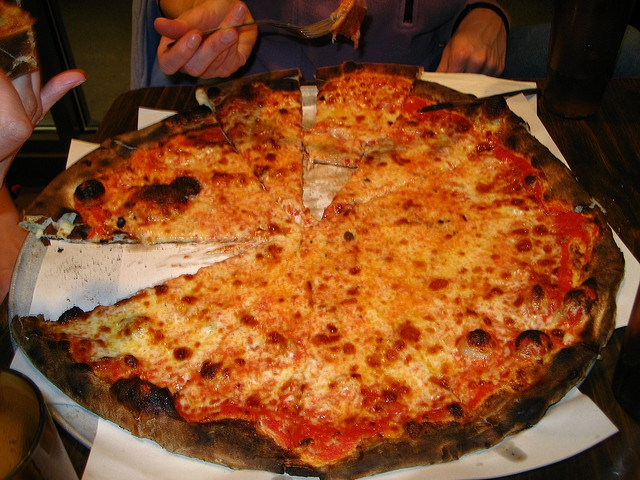Describe the objects in this image and their specific colors. I can see pizza in maroon, red, brown, and orange tones, pizza in maroon, red, and brown tones, people in maroon, black, and brown tones, pizza in maroon, red, and brown tones, and people in maroon and brown tones in this image. 